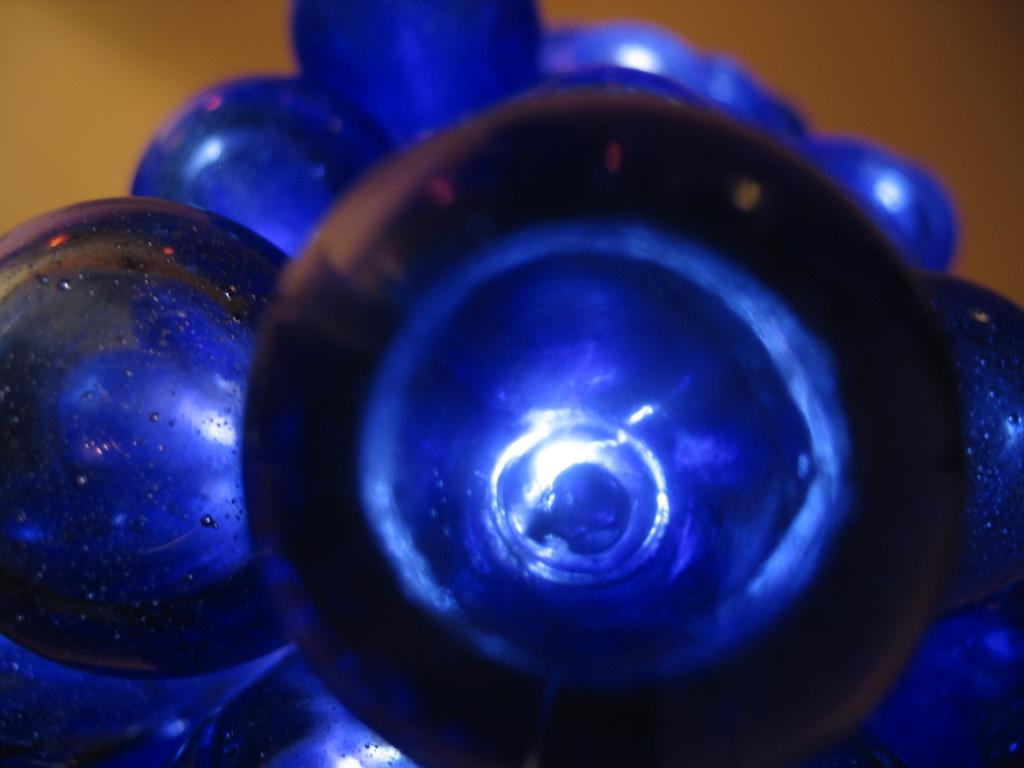What is the main focus of the image? The image provides a close view of an object. What type of camera is used to take the picture of the yoke in the image? There is no camera or yoke present in the image; it only provides a close view of an object. 